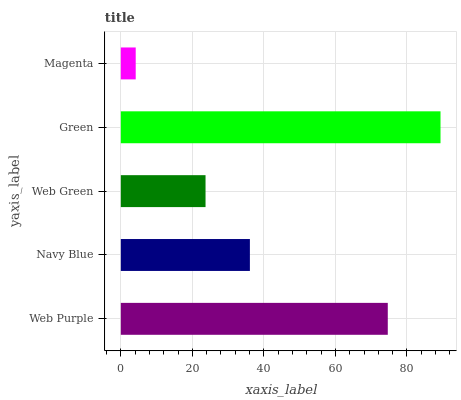Is Magenta the minimum?
Answer yes or no. Yes. Is Green the maximum?
Answer yes or no. Yes. Is Navy Blue the minimum?
Answer yes or no. No. Is Navy Blue the maximum?
Answer yes or no. No. Is Web Purple greater than Navy Blue?
Answer yes or no. Yes. Is Navy Blue less than Web Purple?
Answer yes or no. Yes. Is Navy Blue greater than Web Purple?
Answer yes or no. No. Is Web Purple less than Navy Blue?
Answer yes or no. No. Is Navy Blue the high median?
Answer yes or no. Yes. Is Navy Blue the low median?
Answer yes or no. Yes. Is Web Green the high median?
Answer yes or no. No. Is Green the low median?
Answer yes or no. No. 